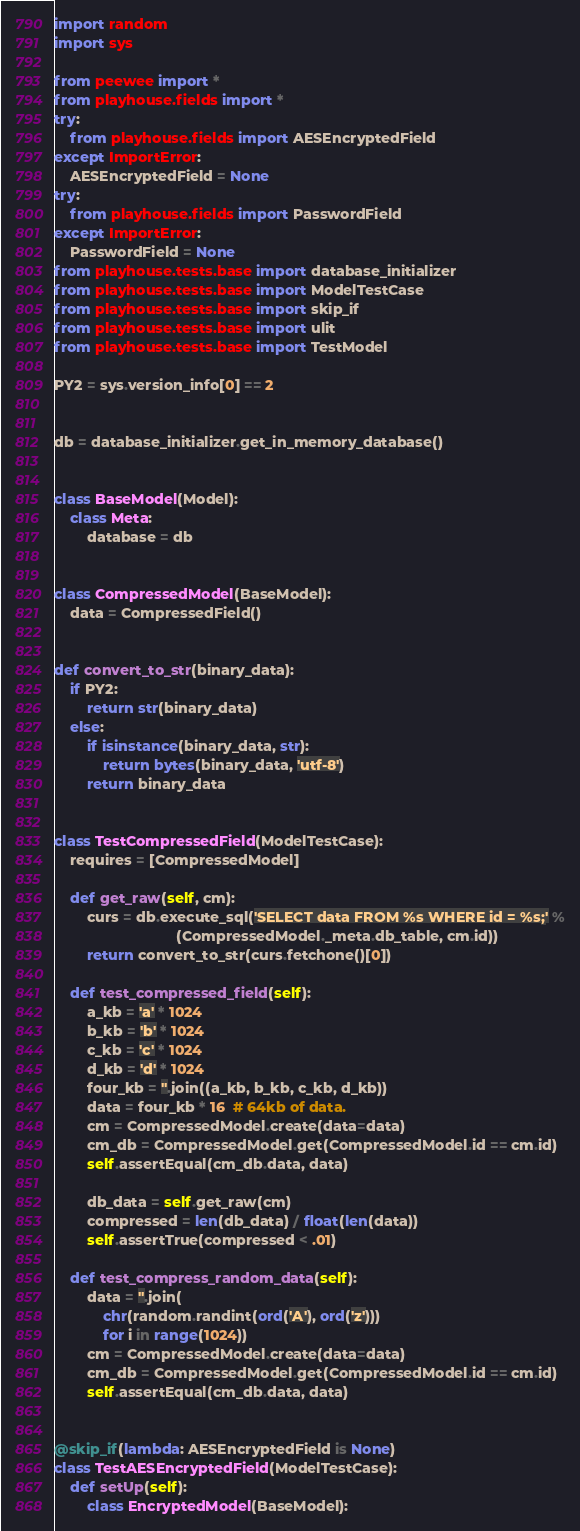Convert code to text. <code><loc_0><loc_0><loc_500><loc_500><_Python_>import random
import sys

from peewee import *
from playhouse.fields import *
try:
    from playhouse.fields import AESEncryptedField
except ImportError:
    AESEncryptedField = None
try:
    from playhouse.fields import PasswordField
except ImportError:
    PasswordField = None
from playhouse.tests.base import database_initializer
from playhouse.tests.base import ModelTestCase
from playhouse.tests.base import skip_if
from playhouse.tests.base import ulit
from playhouse.tests.base import TestModel

PY2 = sys.version_info[0] == 2


db = database_initializer.get_in_memory_database()


class BaseModel(Model):
    class Meta:
        database = db


class CompressedModel(BaseModel):
    data = CompressedField()


def convert_to_str(binary_data):
    if PY2:
        return str(binary_data)
    else:
        if isinstance(binary_data, str):
            return bytes(binary_data, 'utf-8')
        return binary_data


class TestCompressedField(ModelTestCase):
    requires = [CompressedModel]

    def get_raw(self, cm):
        curs = db.execute_sql('SELECT data FROM %s WHERE id = %s;' %
                              (CompressedModel._meta.db_table, cm.id))
        return convert_to_str(curs.fetchone()[0])

    def test_compressed_field(self):
        a_kb = 'a' * 1024
        b_kb = 'b' * 1024
        c_kb = 'c' * 1024
        d_kb = 'd' * 1024
        four_kb = ''.join((a_kb, b_kb, c_kb, d_kb))
        data = four_kb * 16  # 64kb of data.
        cm = CompressedModel.create(data=data)
        cm_db = CompressedModel.get(CompressedModel.id == cm.id)
        self.assertEqual(cm_db.data, data)

        db_data = self.get_raw(cm)
        compressed = len(db_data) / float(len(data))
        self.assertTrue(compressed < .01)

    def test_compress_random_data(self):
        data = ''.join(
            chr(random.randint(ord('A'), ord('z')))
            for i in range(1024))
        cm = CompressedModel.create(data=data)
        cm_db = CompressedModel.get(CompressedModel.id == cm.id)
        self.assertEqual(cm_db.data, data)


@skip_if(lambda: AESEncryptedField is None)
class TestAESEncryptedField(ModelTestCase):
    def setUp(self):
        class EncryptedModel(BaseModel):</code> 